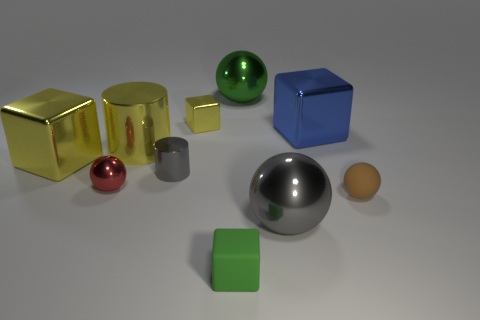Do the gray object that is in front of the tiny shiny cylinder and the large green metallic thing have the same shape?
Your answer should be compact. Yes. Does the metallic thing on the left side of the small metal ball have the same color as the small shiny block?
Keep it short and to the point. Yes. The large metal thing that is the same color as the tiny cylinder is what shape?
Ensure brevity in your answer.  Sphere. Do the tiny ball that is on the left side of the brown rubber object and the cube in front of the small brown ball have the same material?
Your answer should be very brief. No. What color is the large metal cylinder?
Provide a short and direct response. Yellow. How many other small shiny objects have the same shape as the blue shiny thing?
Offer a very short reply. 1. The metal cube that is the same size as the gray metallic cylinder is what color?
Make the answer very short. Yellow. Is there a rubber thing?
Offer a very short reply. Yes. The yellow thing that is behind the large cylinder has what shape?
Keep it short and to the point. Cube. What number of things are behind the small gray cylinder and on the right side of the tiny yellow shiny block?
Provide a succinct answer. 2. 